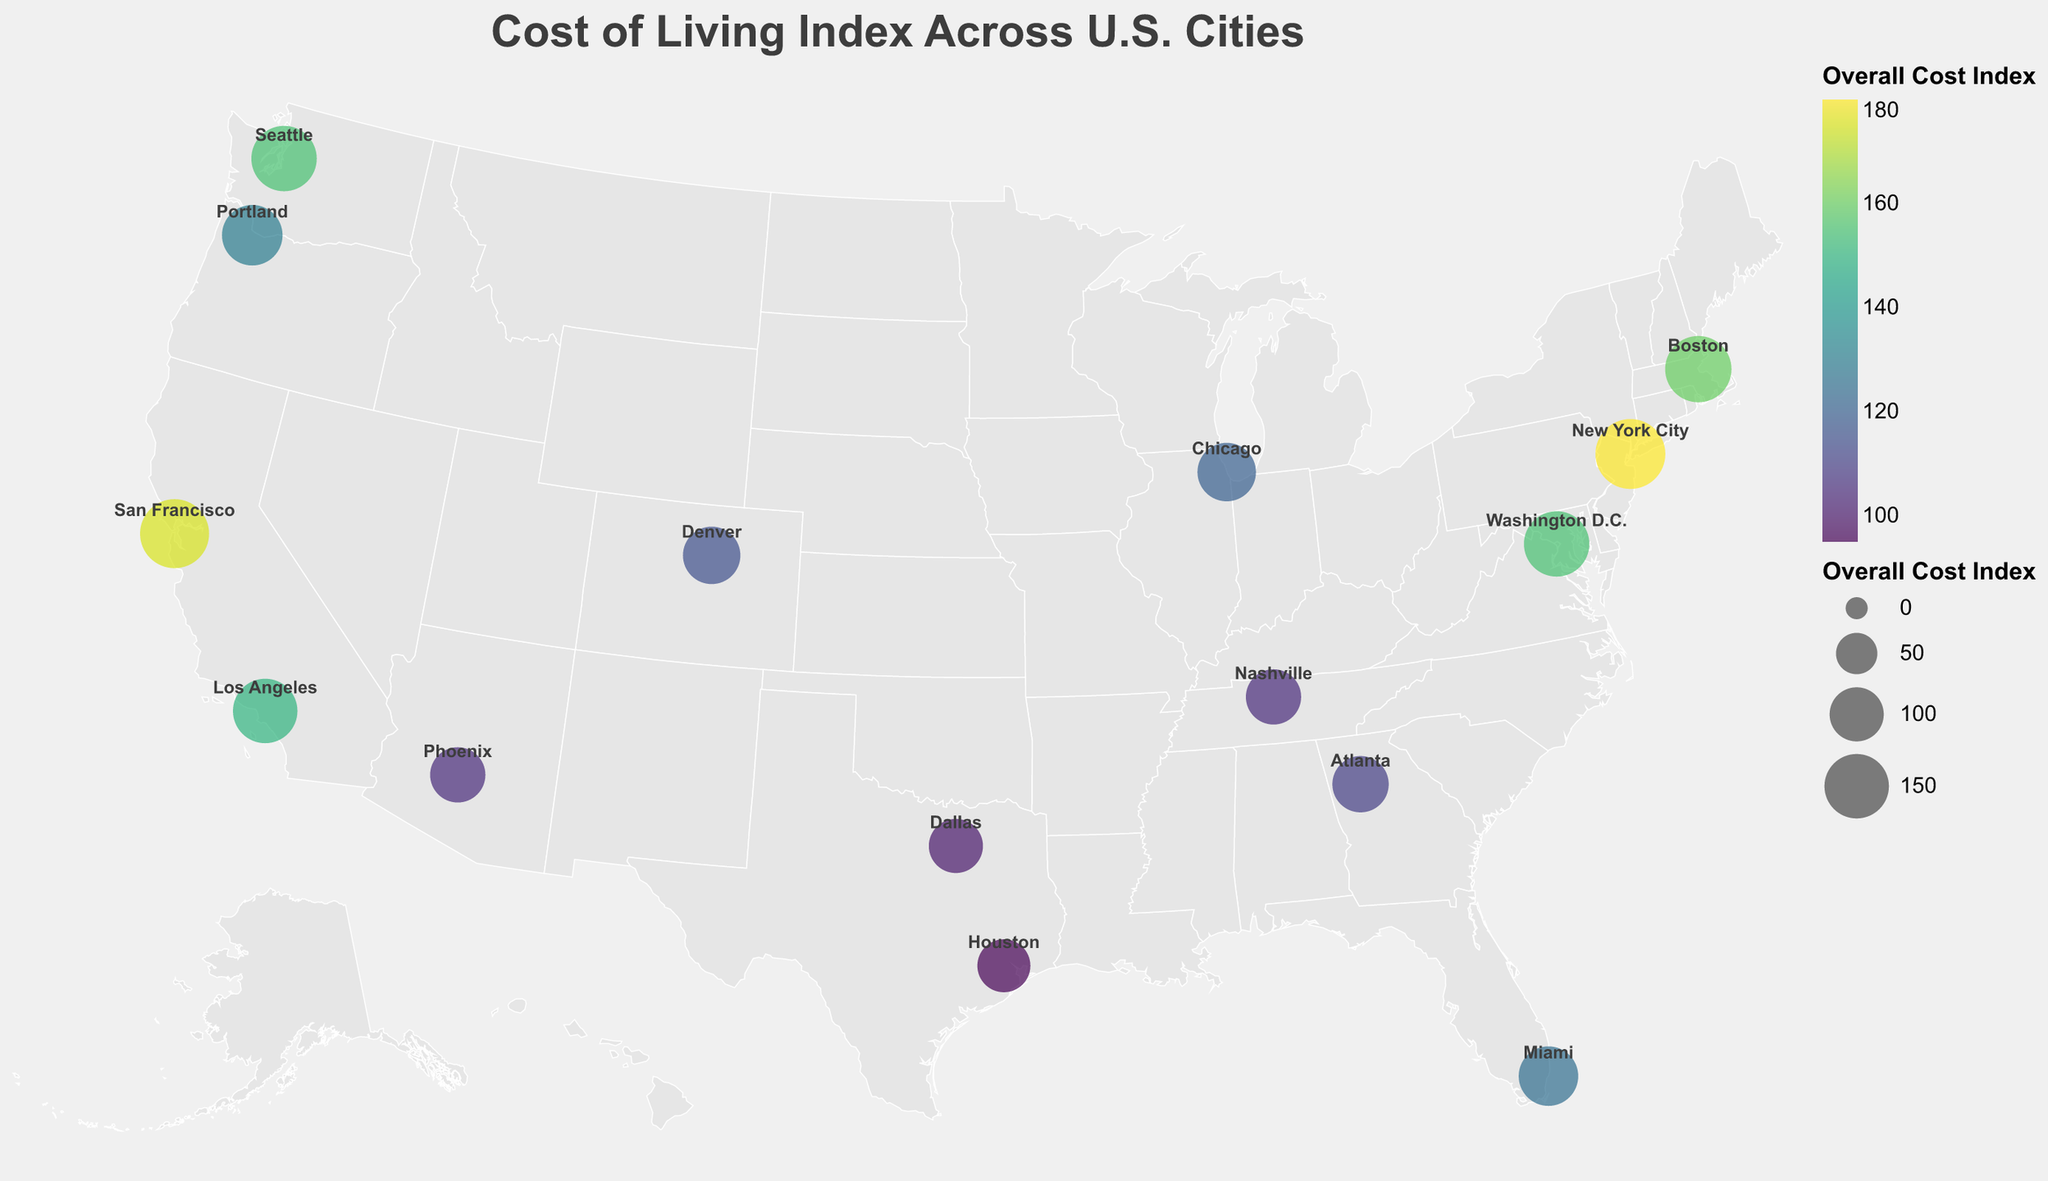How many cities are depicted in the figure? Count the number of city circles on the map. The figure shows a total of 15 cities plotted across the U.S.
Answer: 15 Which city has the highest overall cost index? Look for the city with the largest circle and the highest-value tooltip data point. New York City has the highest overall cost index of 180.
Answer: New York City What is the overall cost index range represented in the figure? Identify the minimum and maximum values for the overall cost index from the city data points. The overall cost index ranges from 95 (Houston) to 180 (New York City).
Answer: 95 to 180 Between cities in California, which one has a lower overall cost index? Compare the overall cost indices of San Francisco (175) and Los Angeles (150) using the city labels and circle sizes. Los Angeles has a lower overall cost index than San Francisco.
Answer: Los Angeles Which city has a lower cost of living, Chicago or Atlanta? Using the tooltips, compare the overall cost indices of Chicago (120) and Atlanta (110). Atlanta has a lower cost of living than Chicago.
Answer: Atlanta What two cities have the same overall cost index, and what is that value? Identify cities with identical circle sizes and confirm with the tooltips. Washington D.C. and Seattle both have an overall cost index of 155.
Answer: Washington D.C. and Seattle, 155 How does the cost of living in Miami compare to Dallas? Examine the overall cost indices for Miami (125) and Dallas (100). Miami has a higher cost of living than Dallas.
Answer: Miami has a higher cost of living What is the average overall cost index for cities plotted on the map? Sum the overall cost indices of all cities (180 + 175 + 150 + 155 + 160 + 155 + 125 + 120 + 95 + 105 + 110 + 115 + 100 + 130 + 105 = 2030) and divide by the number of cities (15). The average overall cost index is 2030 / 15 = 135.3.
Answer: 135.3 Which state has the most cities plotted on the map? Check the states corresponding to the cities plotted. California has the most cities, with San Francisco and Los Angeles.
Answer: California Which city has the smallest circle size on the map, and what is its overall cost index? Identify the city with the smallest circle. Houston has the smallest circle size, with an overall cost index of 95.
Answer: Houston, 95 